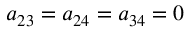Convert formula to latex. <formula><loc_0><loc_0><loc_500><loc_500>a _ { 2 3 } = a _ { 2 4 } = a _ { 3 4 } = 0</formula> 